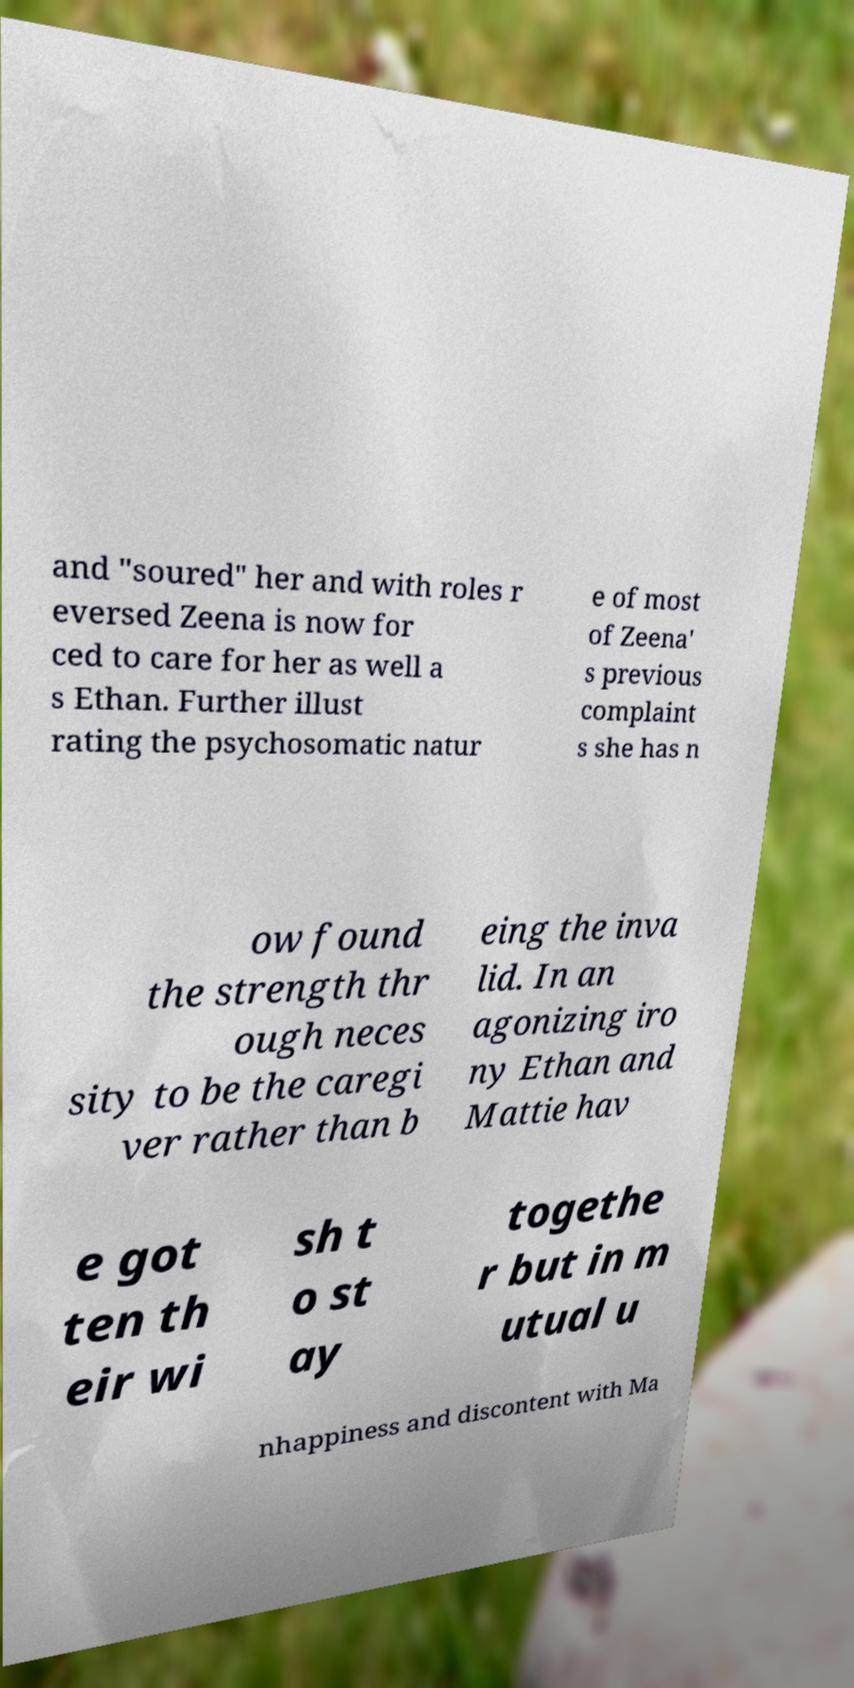What messages or text are displayed in this image? I need them in a readable, typed format. and "soured" her and with roles r eversed Zeena is now for ced to care for her as well a s Ethan. Further illust rating the psychosomatic natur e of most of Zeena' s previous complaint s she has n ow found the strength thr ough neces sity to be the caregi ver rather than b eing the inva lid. In an agonizing iro ny Ethan and Mattie hav e got ten th eir wi sh t o st ay togethe r but in m utual u nhappiness and discontent with Ma 